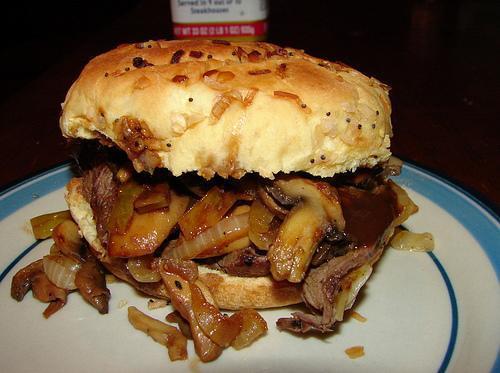How many people rowing are wearing bright green?
Give a very brief answer. 0. 